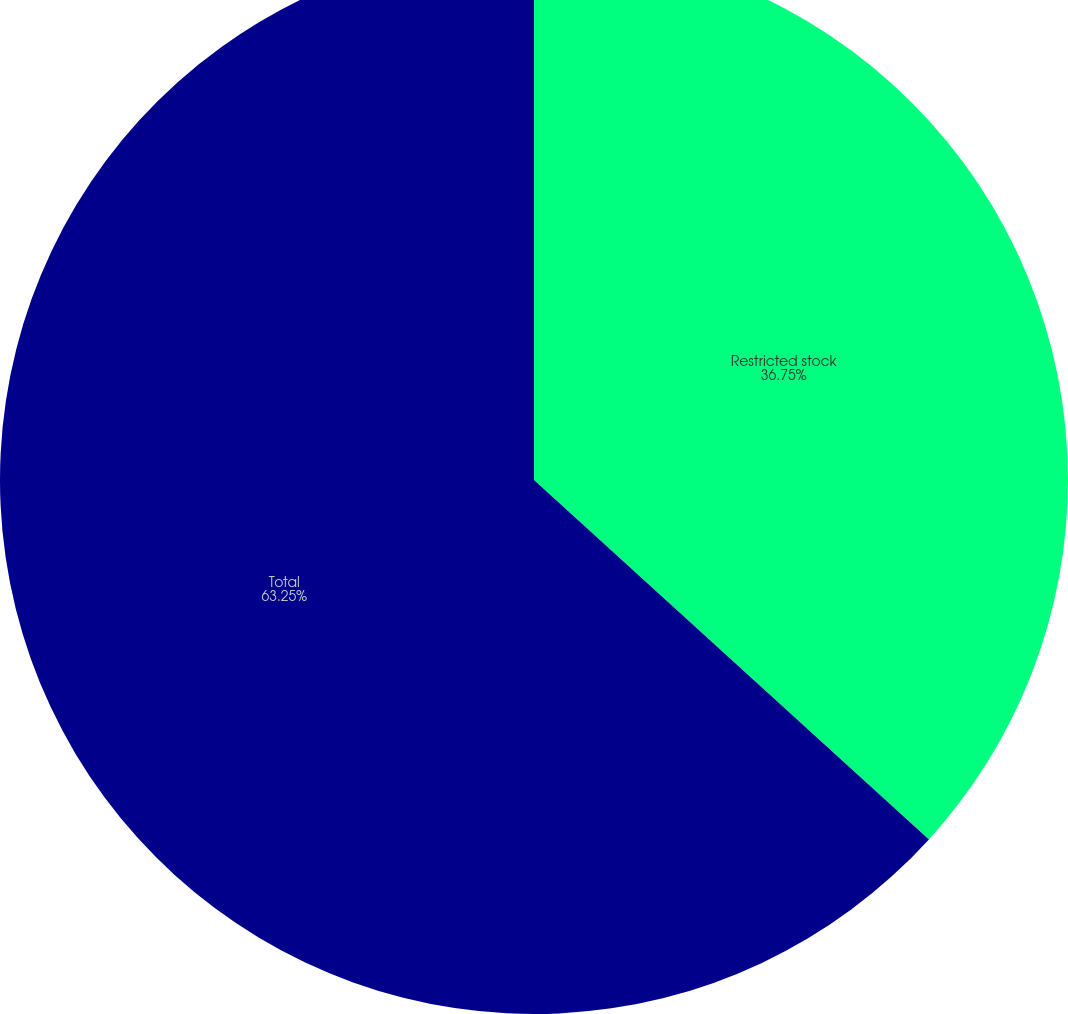<chart> <loc_0><loc_0><loc_500><loc_500><pie_chart><fcel>Restricted stock<fcel>Total<nl><fcel>36.75%<fcel>63.25%<nl></chart> 